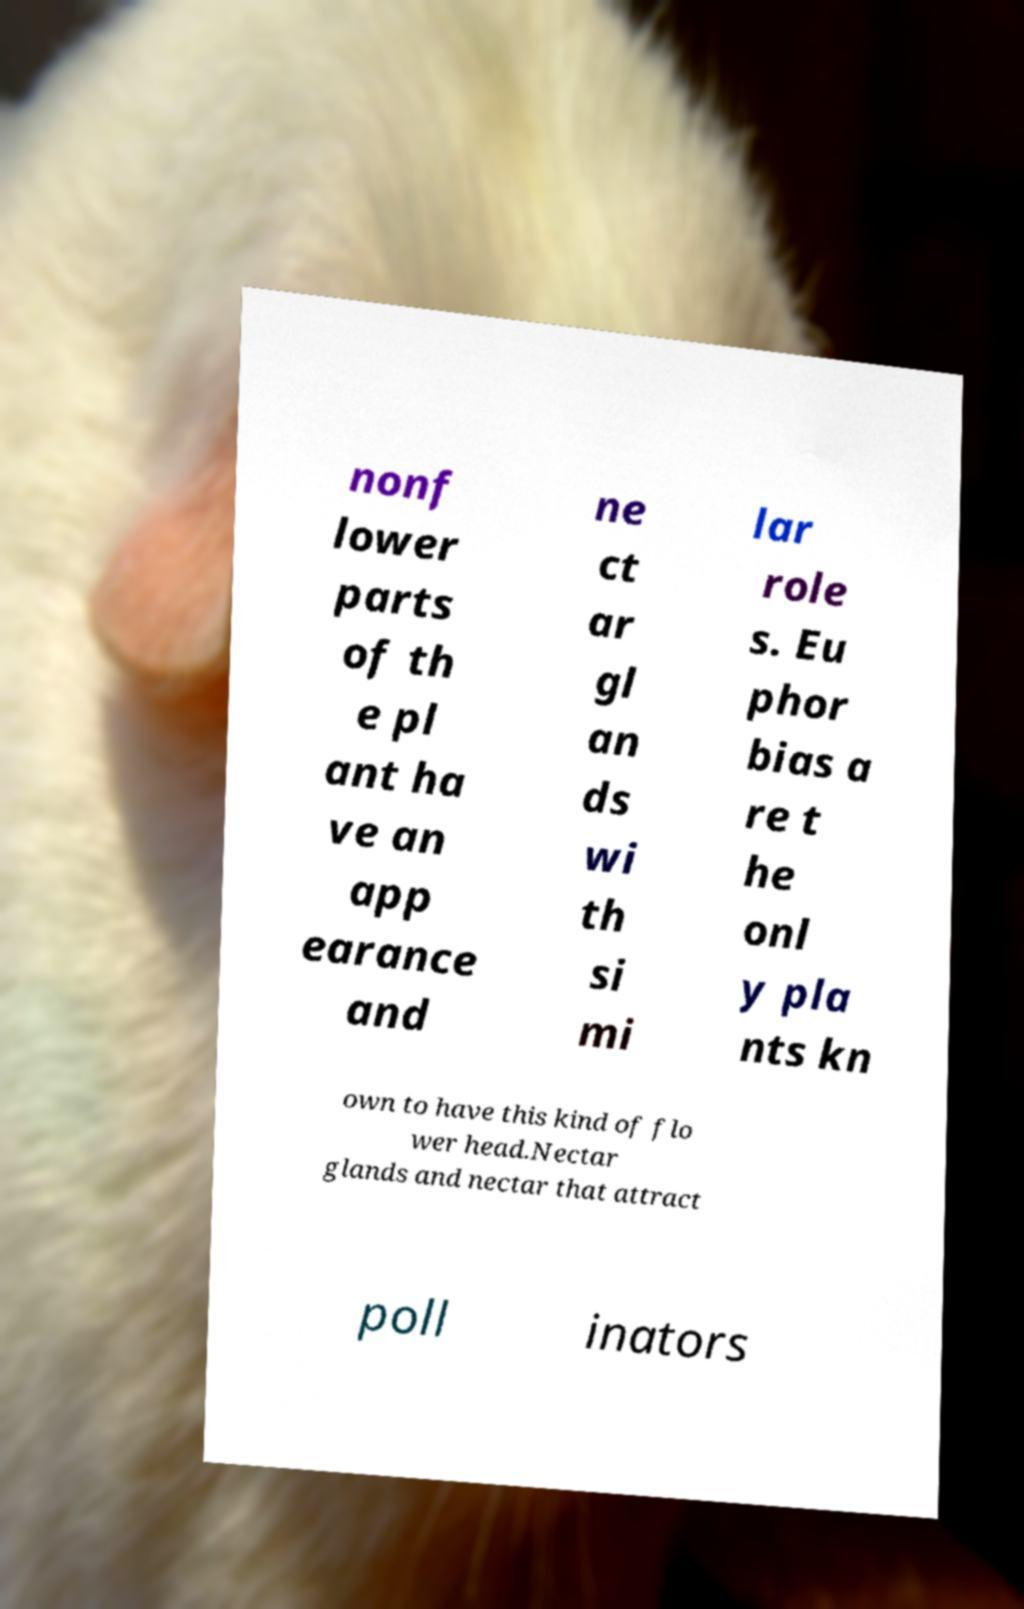Could you assist in decoding the text presented in this image and type it out clearly? nonf lower parts of th e pl ant ha ve an app earance and ne ct ar gl an ds wi th si mi lar role s. Eu phor bias a re t he onl y pla nts kn own to have this kind of flo wer head.Nectar glands and nectar that attract poll inators 